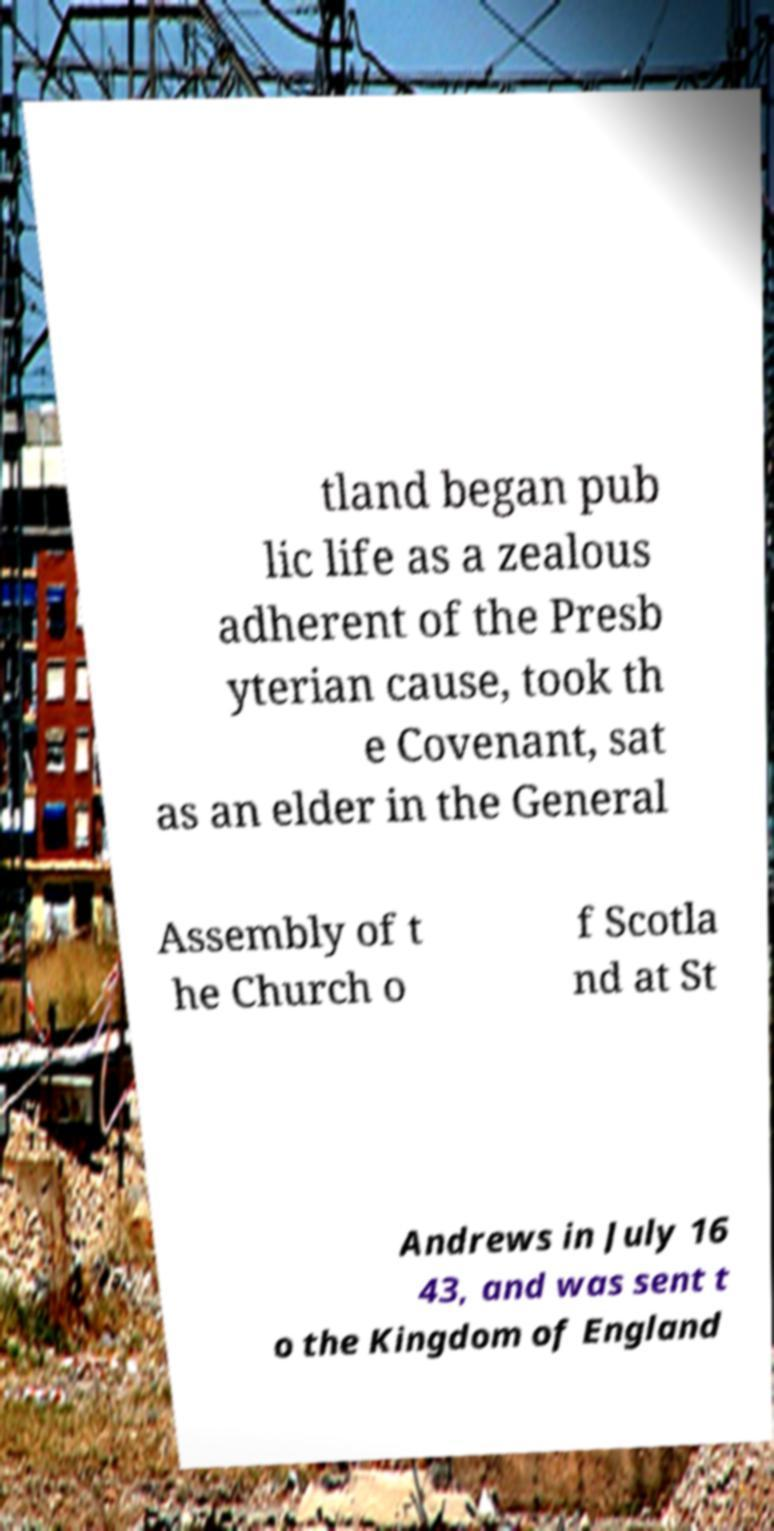I need the written content from this picture converted into text. Can you do that? tland began pub lic life as a zealous adherent of the Presb yterian cause, took th e Covenant, sat as an elder in the General Assembly of t he Church o f Scotla nd at St Andrews in July 16 43, and was sent t o the Kingdom of England 